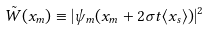<formula> <loc_0><loc_0><loc_500><loc_500>\tilde { W } ( x _ { m } ) \equiv | \psi _ { m } ( x _ { m } + 2 \sigma t \langle x _ { s } \rangle ) | ^ { 2 }</formula> 